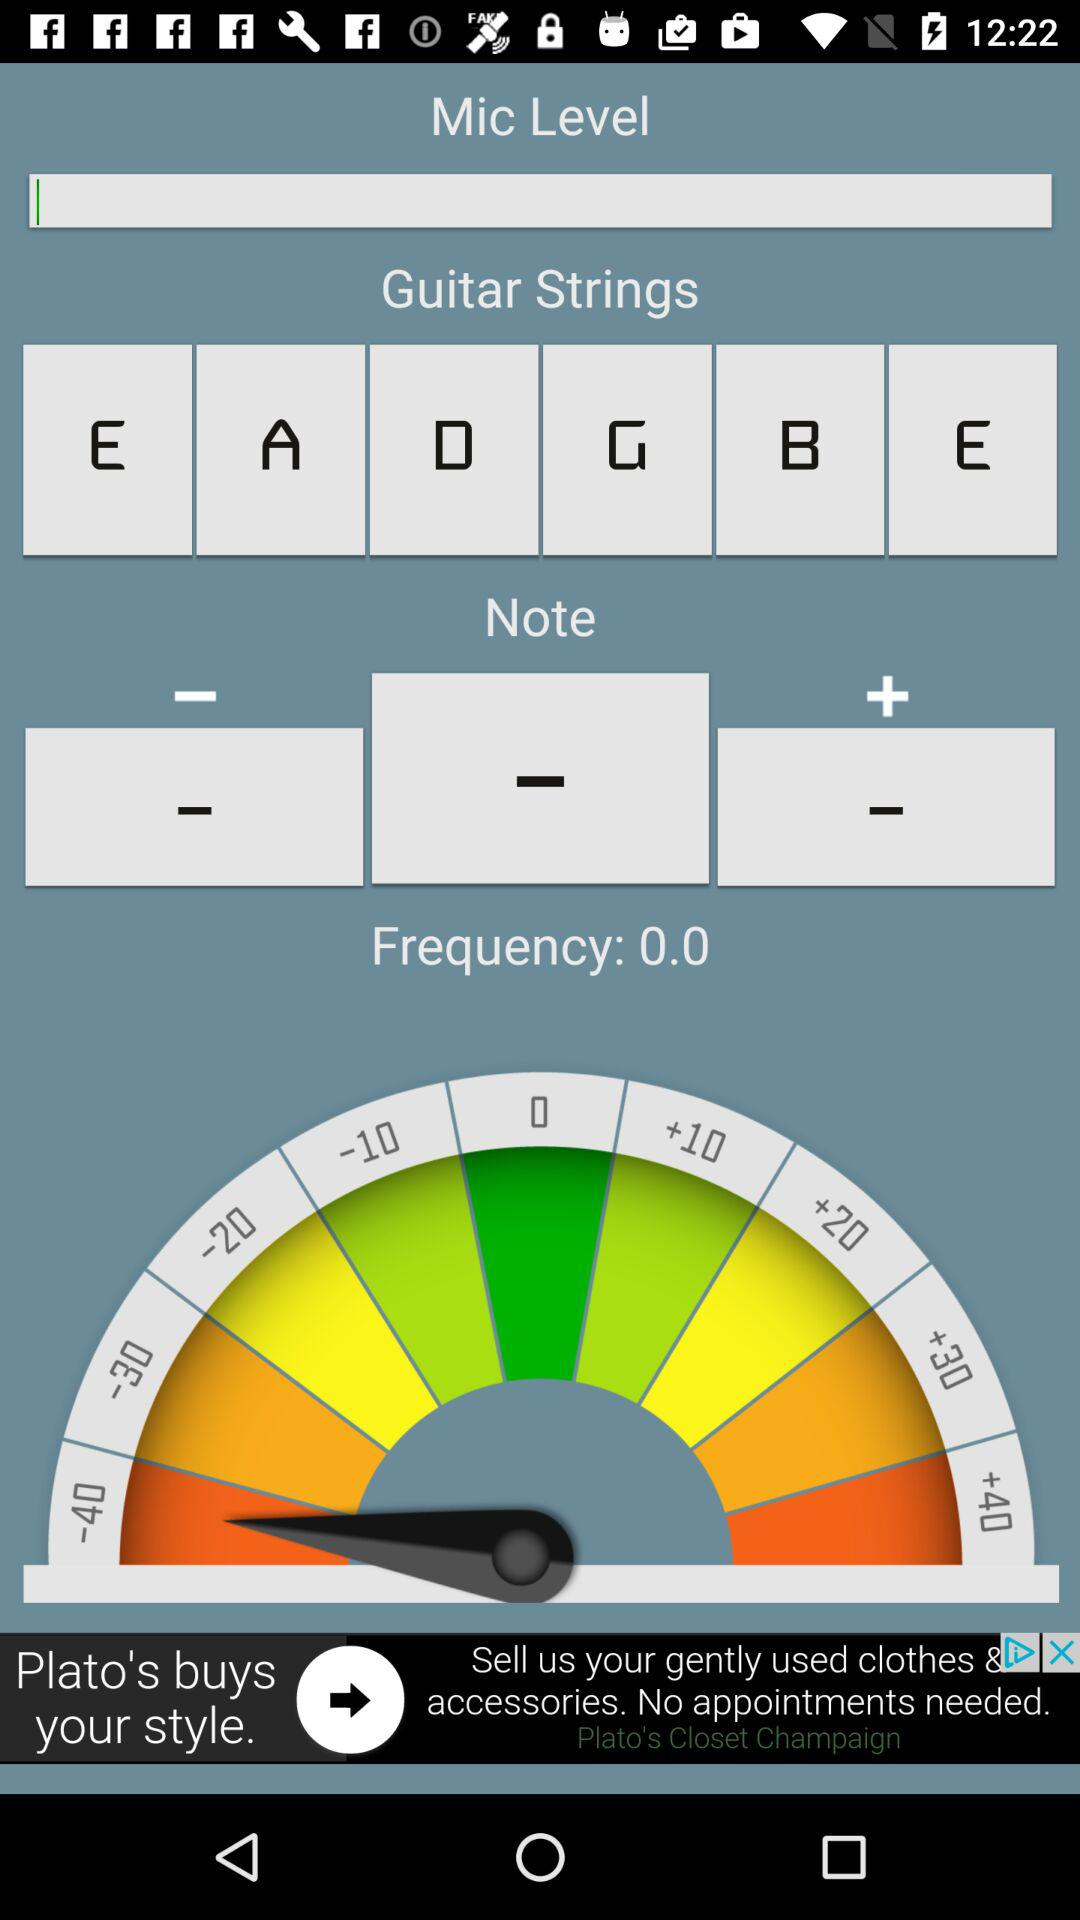What's the frequency? The frequency is 0. 